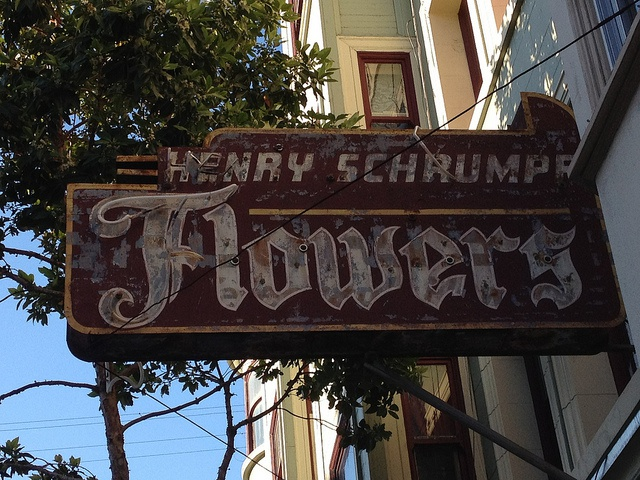Describe the objects in this image and their specific colors. I can see various objects in this image with different colors. 